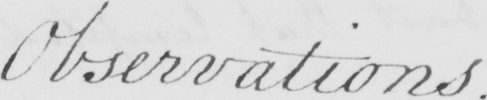Please transcribe the handwritten text in this image. Observations . 